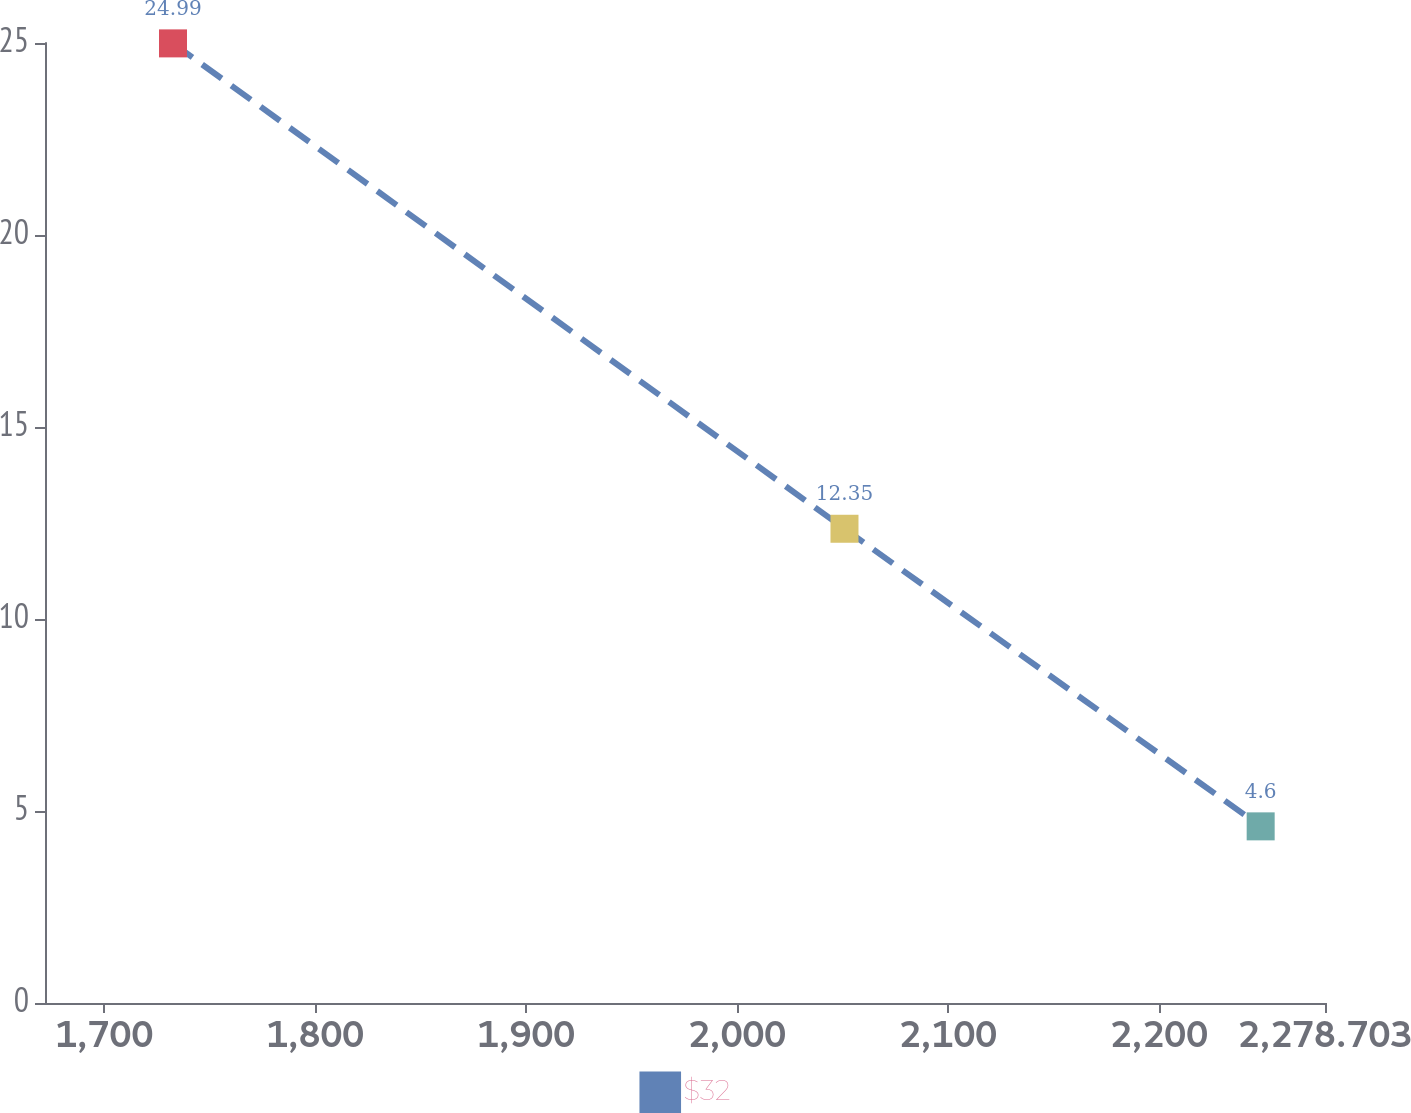<chart> <loc_0><loc_0><loc_500><loc_500><line_chart><ecel><fcel>$32<nl><fcel>1732.61<fcel>24.99<nl><fcel>2050.92<fcel>12.35<nl><fcel>2248.21<fcel>4.6<nl><fcel>2339.38<fcel>2.33<nl></chart> 